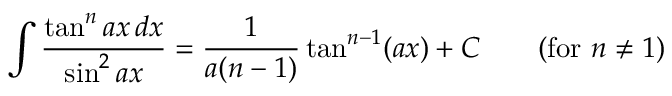<formula> <loc_0><loc_0><loc_500><loc_500>\int { \frac { \tan ^ { n } a x \, d x } { \sin ^ { 2 } a x } } = { \frac { 1 } { a ( n - 1 ) } } \tan ^ { n - 1 } ( a x ) + C \quad { ( f o r } n \neq 1 { ) }</formula> 